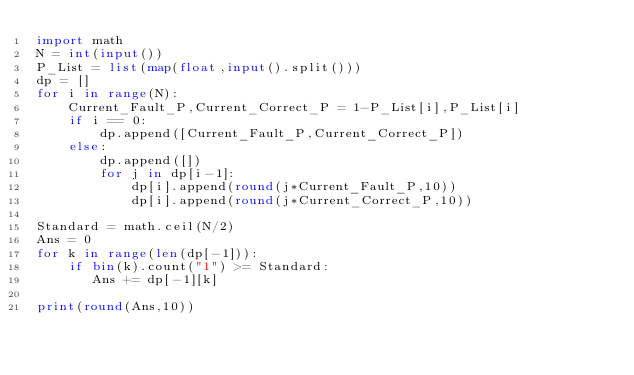<code> <loc_0><loc_0><loc_500><loc_500><_Python_>import math
N = int(input())
P_List = list(map(float,input().split()))
dp = []
for i in range(N):
    Current_Fault_P,Current_Correct_P = 1-P_List[i],P_List[i]
    if i == 0:
        dp.append([Current_Fault_P,Current_Correct_P])
    else:
        dp.append([])
        for j in dp[i-1]:
            dp[i].append(round(j*Current_Fault_P,10))
            dp[i].append(round(j*Current_Correct_P,10))

Standard = math.ceil(N/2)
Ans = 0
for k in range(len(dp[-1])):
    if bin(k).count("1") >= Standard:
       Ans += dp[-1][k]

print(round(Ans,10))</code> 